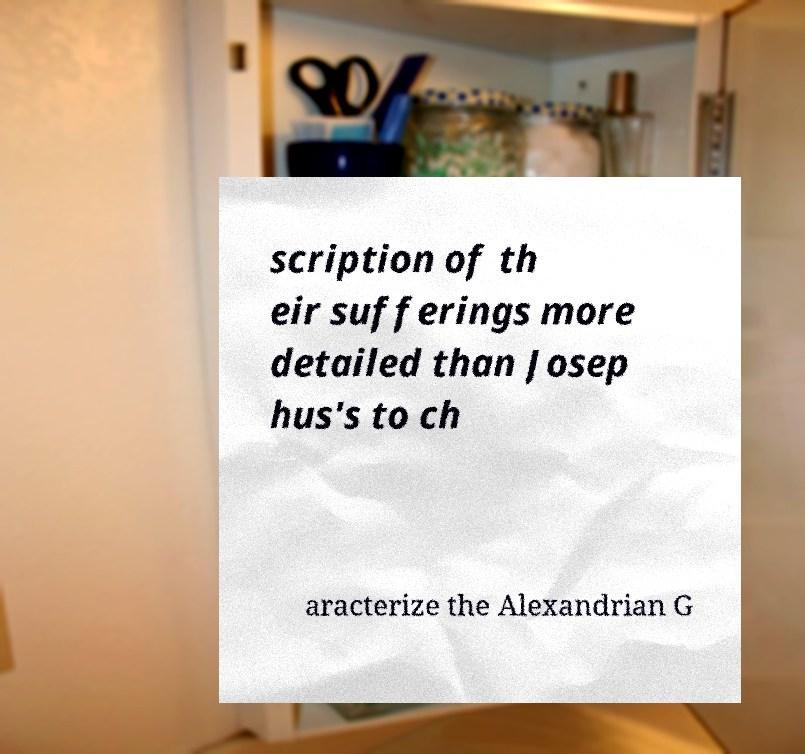For documentation purposes, I need the text within this image transcribed. Could you provide that? scription of th eir sufferings more detailed than Josep hus's to ch aracterize the Alexandrian G 